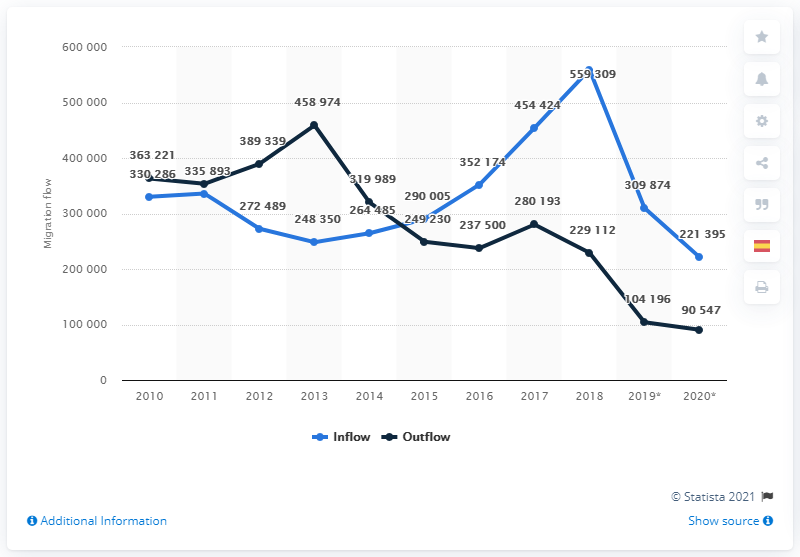Give some essential details in this illustration. For six years, there was more inflow than outflow. In 2013, a total of 458,974 foreign nationals left Spain. In 2018, a total of 559,309 migrants arrived in Spain. The peak of the inflow was reached in 2018. 